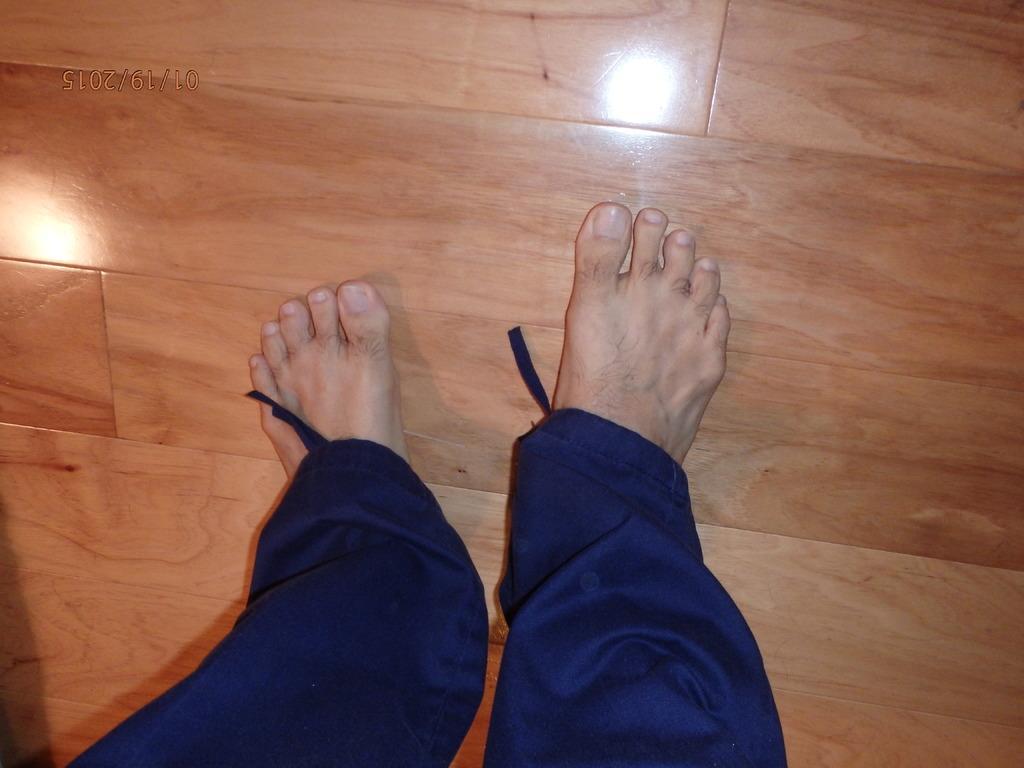Please provide a concise description of this image. We can see a person legs on the floor. Also there is a watermark. 